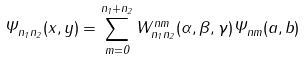Convert formula to latex. <formula><loc_0><loc_0><loc_500><loc_500>\Psi _ { n _ { 1 } n _ { 2 } } ( x , y ) = \sum _ { m = 0 } ^ { n _ { 1 } + n _ { 2 } } W _ { n _ { 1 } n _ { 2 } } ^ { n m } ( \alpha , \beta , \gamma ) \Psi _ { n m } ( a , b )</formula> 